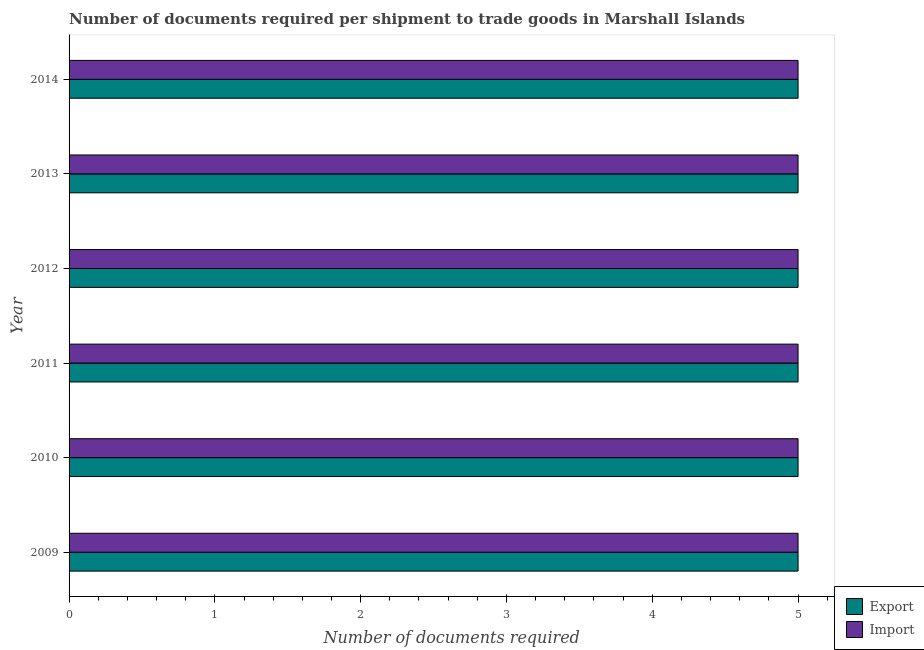How many groups of bars are there?
Ensure brevity in your answer.  6. Are the number of bars on each tick of the Y-axis equal?
Your answer should be very brief. Yes. How many bars are there on the 1st tick from the top?
Your response must be concise. 2. How many bars are there on the 1st tick from the bottom?
Offer a terse response. 2. What is the label of the 3rd group of bars from the top?
Your response must be concise. 2012. What is the number of documents required to import goods in 2010?
Offer a very short reply. 5. Across all years, what is the maximum number of documents required to export goods?
Keep it short and to the point. 5. Across all years, what is the minimum number of documents required to import goods?
Your response must be concise. 5. What is the total number of documents required to import goods in the graph?
Offer a terse response. 30. What is the difference between the number of documents required to import goods in 2014 and the number of documents required to export goods in 2013?
Ensure brevity in your answer.  0. In the year 2013, what is the difference between the number of documents required to export goods and number of documents required to import goods?
Provide a short and direct response. 0. In how many years, is the number of documents required to import goods greater than 2.4 ?
Your answer should be very brief. 6. What is the ratio of the number of documents required to export goods in 2012 to that in 2014?
Ensure brevity in your answer.  1. Is the difference between the number of documents required to export goods in 2010 and 2013 greater than the difference between the number of documents required to import goods in 2010 and 2013?
Keep it short and to the point. No. What does the 2nd bar from the top in 2013 represents?
Offer a very short reply. Export. What does the 2nd bar from the bottom in 2010 represents?
Your answer should be very brief. Import. How many years are there in the graph?
Your answer should be compact. 6. Are the values on the major ticks of X-axis written in scientific E-notation?
Make the answer very short. No. Does the graph contain grids?
Ensure brevity in your answer.  No. What is the title of the graph?
Your answer should be compact. Number of documents required per shipment to trade goods in Marshall Islands. What is the label or title of the X-axis?
Provide a short and direct response. Number of documents required. What is the Number of documents required in Export in 2009?
Your answer should be very brief. 5. What is the Number of documents required in Import in 2009?
Keep it short and to the point. 5. What is the Number of documents required of Import in 2010?
Offer a terse response. 5. What is the Number of documents required of Export in 2011?
Ensure brevity in your answer.  5. What is the Number of documents required of Import in 2011?
Keep it short and to the point. 5. What is the Number of documents required of Export in 2013?
Ensure brevity in your answer.  5. What is the Number of documents required in Import in 2013?
Provide a short and direct response. 5. What is the Number of documents required of Export in 2014?
Give a very brief answer. 5. Across all years, what is the maximum Number of documents required in Export?
Make the answer very short. 5. Across all years, what is the maximum Number of documents required in Import?
Your answer should be very brief. 5. Across all years, what is the minimum Number of documents required in Export?
Ensure brevity in your answer.  5. Across all years, what is the minimum Number of documents required in Import?
Provide a succinct answer. 5. What is the total Number of documents required of Import in the graph?
Provide a succinct answer. 30. What is the difference between the Number of documents required of Import in 2009 and that in 2010?
Your response must be concise. 0. What is the difference between the Number of documents required of Export in 2009 and that in 2012?
Your answer should be very brief. 0. What is the difference between the Number of documents required of Import in 2009 and that in 2012?
Provide a succinct answer. 0. What is the difference between the Number of documents required of Export in 2009 and that in 2013?
Ensure brevity in your answer.  0. What is the difference between the Number of documents required of Import in 2009 and that in 2013?
Your answer should be compact. 0. What is the difference between the Number of documents required in Export in 2009 and that in 2014?
Give a very brief answer. 0. What is the difference between the Number of documents required in Import in 2009 and that in 2014?
Offer a terse response. 0. What is the difference between the Number of documents required in Export in 2010 and that in 2011?
Offer a very short reply. 0. What is the difference between the Number of documents required in Import in 2010 and that in 2012?
Provide a short and direct response. 0. What is the difference between the Number of documents required in Import in 2011 and that in 2013?
Provide a succinct answer. 0. What is the difference between the Number of documents required in Import in 2011 and that in 2014?
Make the answer very short. 0. What is the difference between the Number of documents required of Export in 2012 and that in 2013?
Keep it short and to the point. 0. What is the difference between the Number of documents required of Export in 2013 and that in 2014?
Your answer should be very brief. 0. What is the difference between the Number of documents required of Import in 2013 and that in 2014?
Your response must be concise. 0. What is the difference between the Number of documents required in Export in 2009 and the Number of documents required in Import in 2012?
Your answer should be compact. 0. What is the difference between the Number of documents required of Export in 2009 and the Number of documents required of Import in 2013?
Keep it short and to the point. 0. What is the difference between the Number of documents required of Export in 2009 and the Number of documents required of Import in 2014?
Offer a terse response. 0. What is the difference between the Number of documents required of Export in 2010 and the Number of documents required of Import in 2012?
Offer a very short reply. 0. What is the difference between the Number of documents required in Export in 2011 and the Number of documents required in Import in 2012?
Your response must be concise. 0. What is the difference between the Number of documents required in Export in 2011 and the Number of documents required in Import in 2014?
Your response must be concise. 0. What is the difference between the Number of documents required of Export in 2013 and the Number of documents required of Import in 2014?
Keep it short and to the point. 0. In the year 2009, what is the difference between the Number of documents required in Export and Number of documents required in Import?
Ensure brevity in your answer.  0. In the year 2011, what is the difference between the Number of documents required in Export and Number of documents required in Import?
Offer a very short reply. 0. In the year 2013, what is the difference between the Number of documents required of Export and Number of documents required of Import?
Make the answer very short. 0. What is the ratio of the Number of documents required of Export in 2009 to that in 2010?
Provide a succinct answer. 1. What is the ratio of the Number of documents required of Export in 2009 to that in 2012?
Offer a terse response. 1. What is the ratio of the Number of documents required in Import in 2009 to that in 2012?
Keep it short and to the point. 1. What is the ratio of the Number of documents required of Import in 2009 to that in 2014?
Provide a succinct answer. 1. What is the ratio of the Number of documents required of Export in 2010 to that in 2011?
Offer a very short reply. 1. What is the ratio of the Number of documents required of Import in 2010 to that in 2013?
Your response must be concise. 1. What is the ratio of the Number of documents required in Export in 2011 to that in 2013?
Give a very brief answer. 1. What is the ratio of the Number of documents required in Export in 2011 to that in 2014?
Offer a very short reply. 1. What is the ratio of the Number of documents required of Export in 2012 to that in 2013?
Your response must be concise. 1. What is the ratio of the Number of documents required of Import in 2012 to that in 2013?
Ensure brevity in your answer.  1. What is the ratio of the Number of documents required in Export in 2012 to that in 2014?
Provide a succinct answer. 1. What is the ratio of the Number of documents required of Import in 2012 to that in 2014?
Keep it short and to the point. 1. What is the ratio of the Number of documents required in Export in 2013 to that in 2014?
Your response must be concise. 1. What is the ratio of the Number of documents required in Import in 2013 to that in 2014?
Give a very brief answer. 1. What is the difference between the highest and the lowest Number of documents required in Import?
Offer a terse response. 0. 